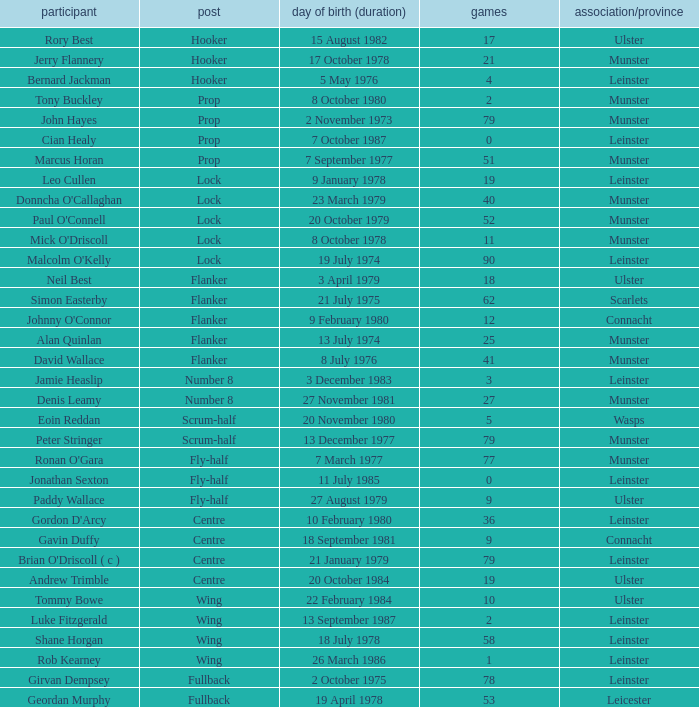What is the total of Caps when player born 13 December 1977? 79.0. 